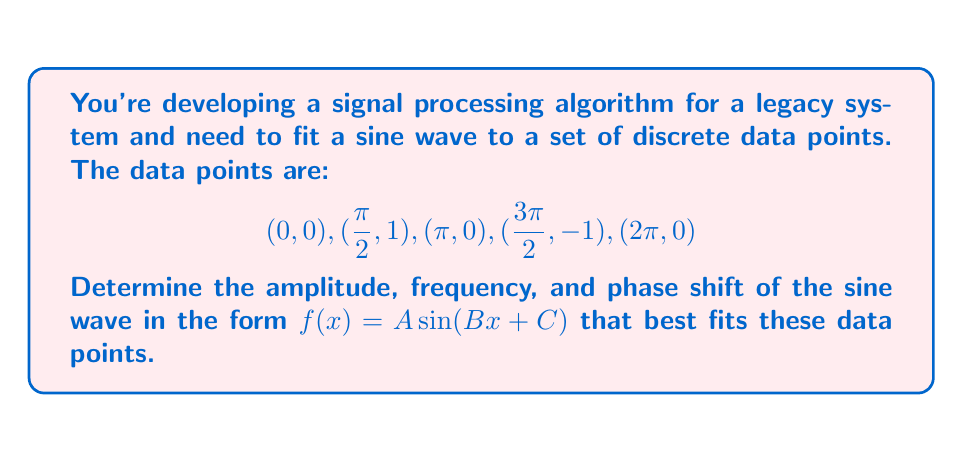Can you answer this question? To solve this problem, we'll follow these steps:

1) The general form of a sine wave is $f(x) = A \sin(Bx + C)$, where:
   $A$ is the amplitude
   $B$ is the angular frequency
   $C$ is the phase shift

2) From the given data points, we can observe:
   - The wave completes one full cycle over $2\pi$, so $B = 1$
   - The amplitude is 1, so $A = 1$
   - The wave starts at 0 and reaches its peak at $\frac{\pi}{2}$, so there's no phase shift, meaning $C = 0$

3) Let's verify these parameters fit all given points:

   For $x = 0$: $f(0) = 1 \sin(1 \cdot 0 + 0) = 0$
   For $x = \frac{\pi}{2}$: $f(\frac{\pi}{2}) = 1 \sin(1 \cdot \frac{\pi}{2} + 0) = 1$
   For $x = \pi$: $f(\pi) = 1 \sin(1 \cdot \pi + 0) = 0$
   For $x = \frac{3\pi}{2}$: $f(\frac{3\pi}{2}) = 1 \sin(1 \cdot \frac{3\pi}{2} + 0) = -1$
   For $x = 2\pi$: $f(2\pi) = 1 \sin(1 \cdot 2\pi + 0) = 0$

4) These results match all given data points, confirming our parameter choices.
Answer: The sine wave that best fits the given data points is:

$$f(x) = 1 \sin(x)$$

Where:
$A = 1$ (amplitude)
$B = 1$ (frequency)
$C = 0$ (phase shift) 